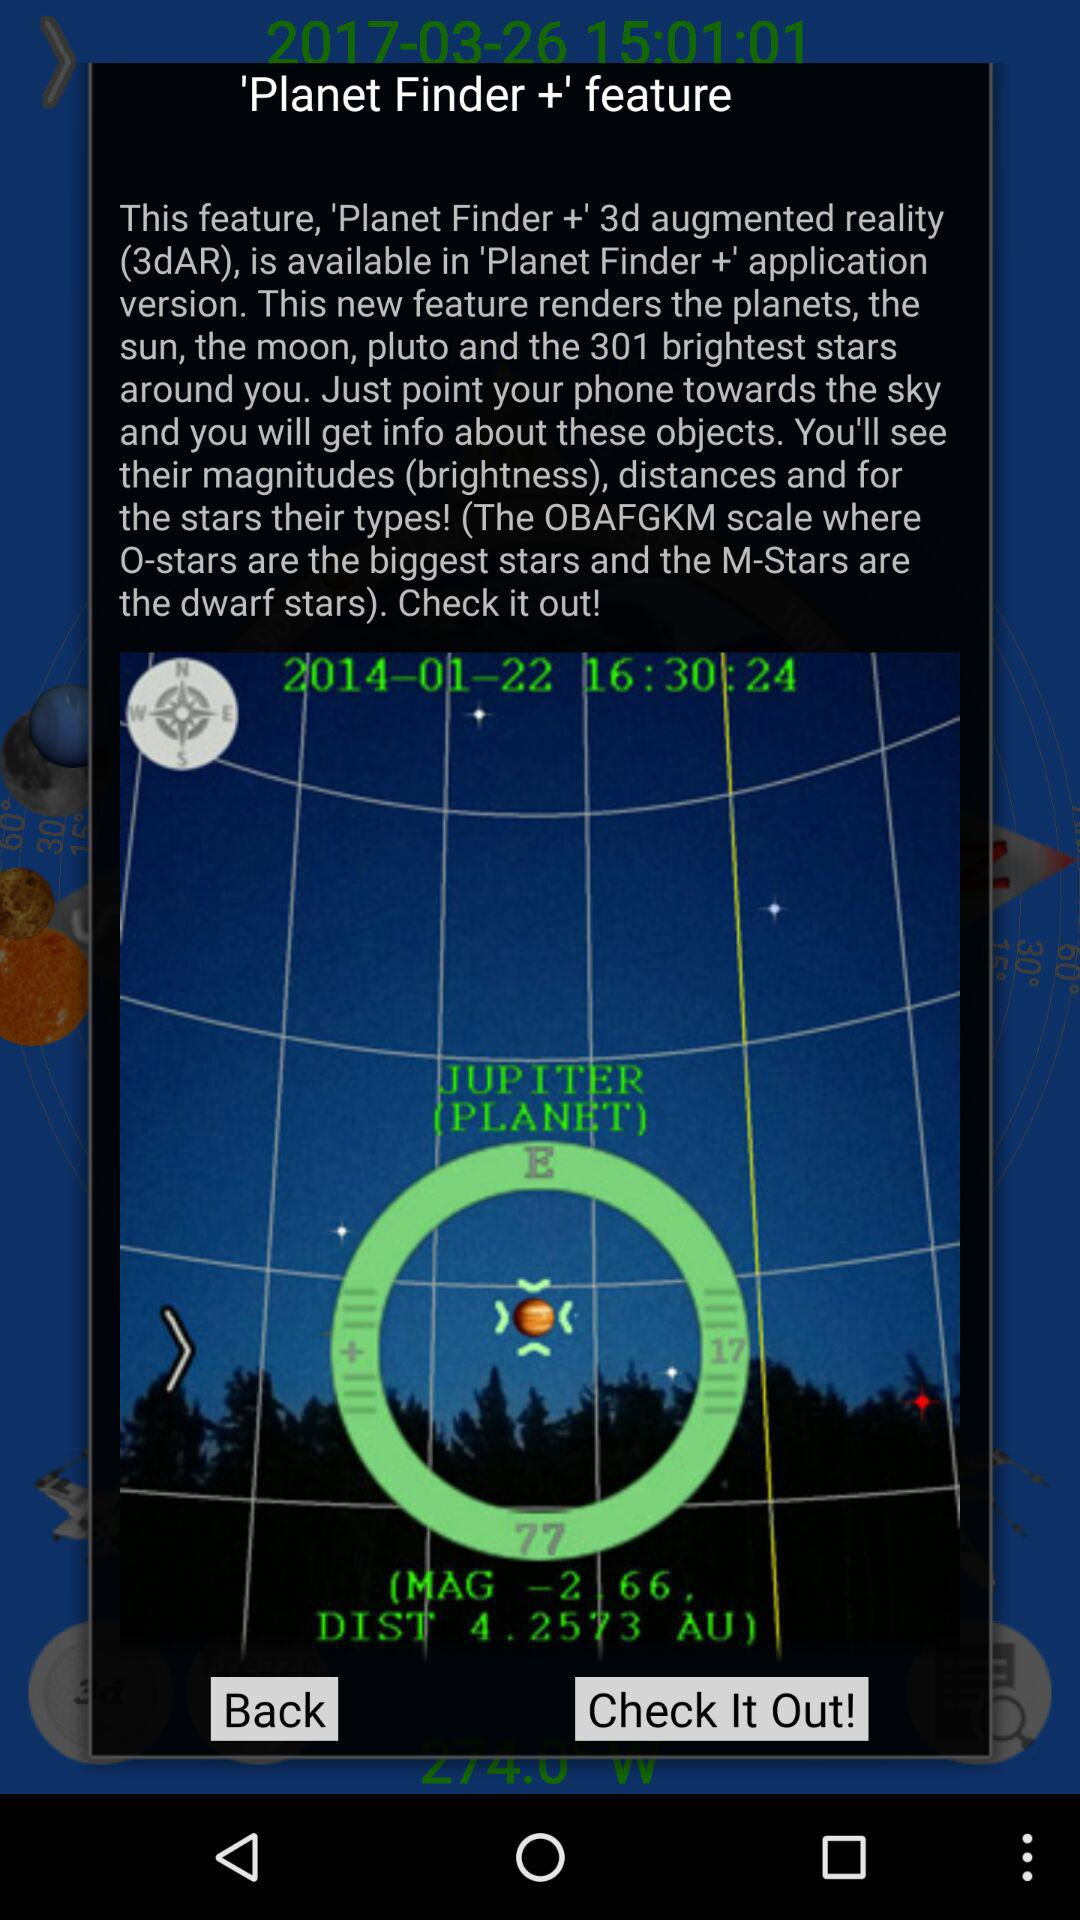Which planet is shown? The shown planet is Jupiter. 